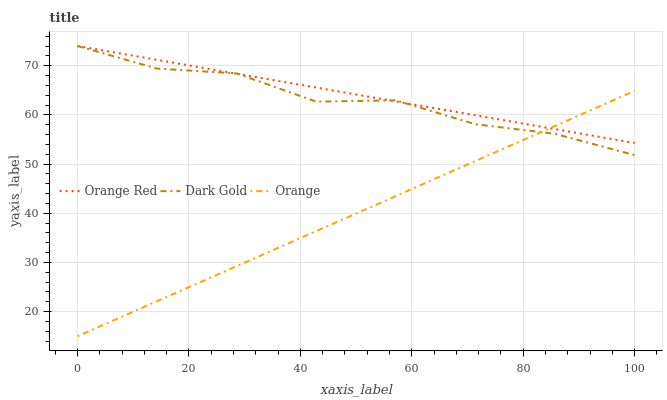Does Orange have the minimum area under the curve?
Answer yes or no. Yes. Does Orange Red have the maximum area under the curve?
Answer yes or no. Yes. Does Dark Gold have the minimum area under the curve?
Answer yes or no. No. Does Dark Gold have the maximum area under the curve?
Answer yes or no. No. Is Orange the smoothest?
Answer yes or no. Yes. Is Dark Gold the roughest?
Answer yes or no. Yes. Is Orange Red the smoothest?
Answer yes or no. No. Is Orange Red the roughest?
Answer yes or no. No. Does Dark Gold have the lowest value?
Answer yes or no. No. 